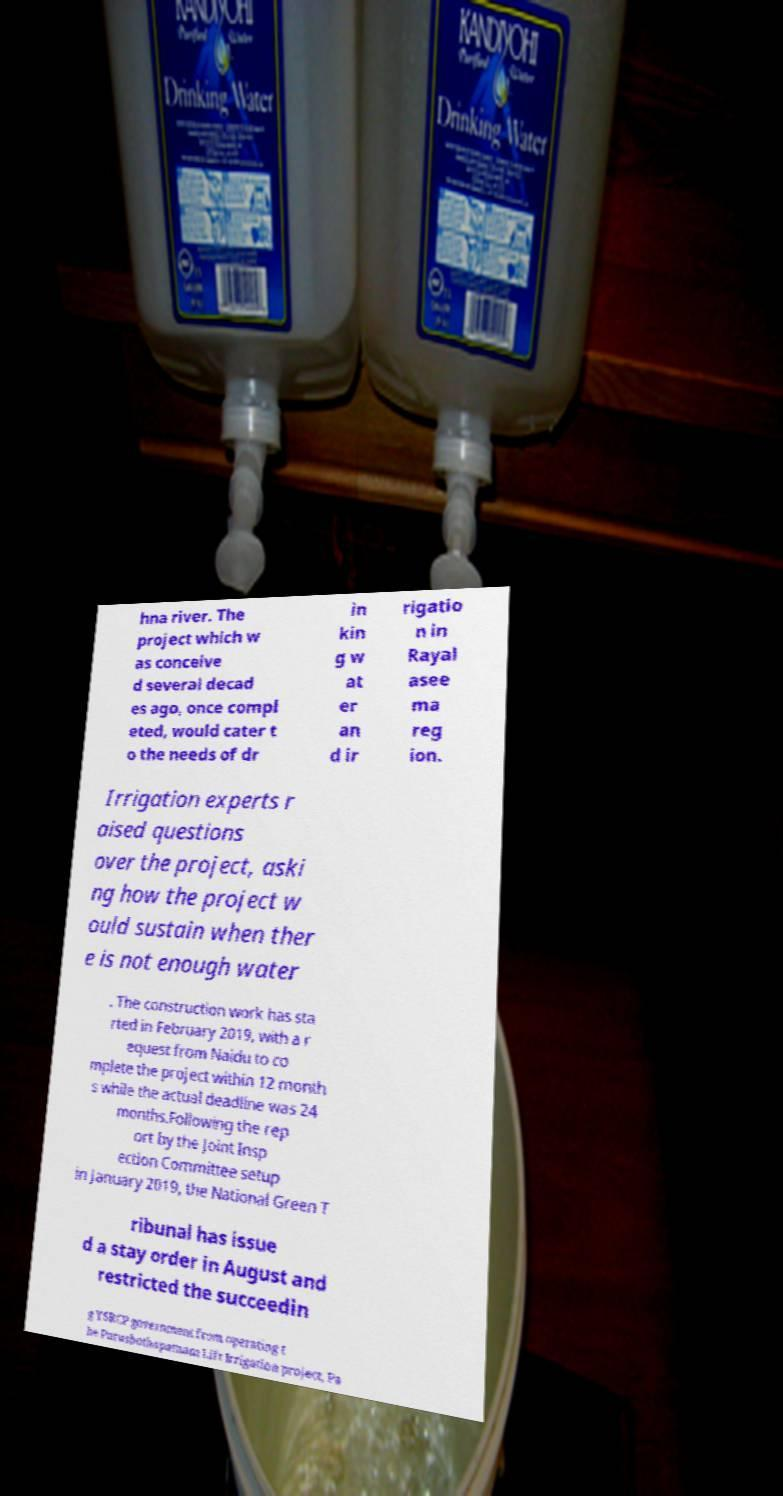There's text embedded in this image that I need extracted. Can you transcribe it verbatim? hna river. The project which w as conceive d several decad es ago, once compl eted, would cater t o the needs of dr in kin g w at er an d ir rigatio n in Rayal asee ma reg ion. Irrigation experts r aised questions over the project, aski ng how the project w ould sustain when ther e is not enough water . The construction work has sta rted in February 2019, with a r equest from Naidu to co mplete the project within 12 month s while the actual deadline was 24 months.Following the rep ort by the Joint Insp ection Committee setup in January 2019, the National Green T ribunal has issue d a stay order in August and restricted the succeedin g YSRCP government from operating t he Purushothapatnam Lift Irrigation project, Pa 